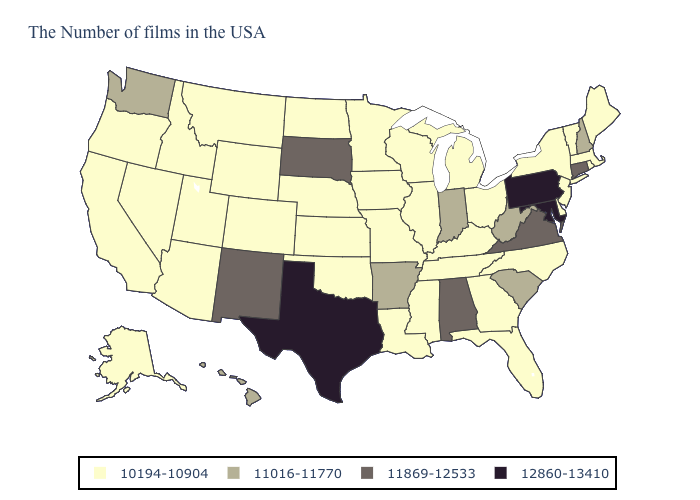Does West Virginia have the highest value in the USA?
Give a very brief answer. No. Name the states that have a value in the range 10194-10904?
Give a very brief answer. Maine, Massachusetts, Rhode Island, Vermont, New York, New Jersey, Delaware, North Carolina, Ohio, Florida, Georgia, Michigan, Kentucky, Tennessee, Wisconsin, Illinois, Mississippi, Louisiana, Missouri, Minnesota, Iowa, Kansas, Nebraska, Oklahoma, North Dakota, Wyoming, Colorado, Utah, Montana, Arizona, Idaho, Nevada, California, Oregon, Alaska. Name the states that have a value in the range 11016-11770?
Quick response, please. New Hampshire, South Carolina, West Virginia, Indiana, Arkansas, Washington, Hawaii. Does Vermont have the lowest value in the Northeast?
Be succinct. Yes. What is the lowest value in the South?
Short answer required. 10194-10904. Does South Dakota have a lower value than Minnesota?
Quick response, please. No. Name the states that have a value in the range 10194-10904?
Keep it brief. Maine, Massachusetts, Rhode Island, Vermont, New York, New Jersey, Delaware, North Carolina, Ohio, Florida, Georgia, Michigan, Kentucky, Tennessee, Wisconsin, Illinois, Mississippi, Louisiana, Missouri, Minnesota, Iowa, Kansas, Nebraska, Oklahoma, North Dakota, Wyoming, Colorado, Utah, Montana, Arizona, Idaho, Nevada, California, Oregon, Alaska. Is the legend a continuous bar?
Keep it brief. No. Among the states that border Texas , does New Mexico have the lowest value?
Write a very short answer. No. What is the value of Vermont?
Write a very short answer. 10194-10904. Name the states that have a value in the range 11869-12533?
Answer briefly. Connecticut, Virginia, Alabama, South Dakota, New Mexico. What is the lowest value in the Northeast?
Short answer required. 10194-10904. Name the states that have a value in the range 12860-13410?
Quick response, please. Maryland, Pennsylvania, Texas. 